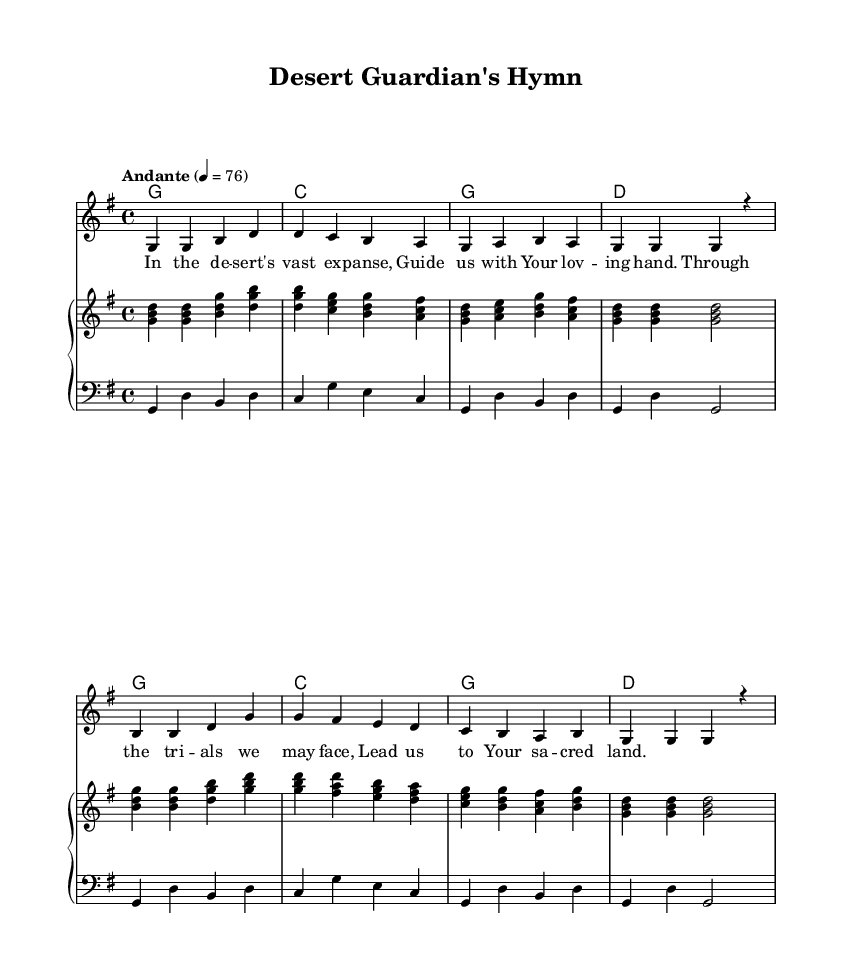What is the key signature of this music? The key signature is G major, which has one sharp (F#). You can identify the key signature by looking at the clef and the accidentals at the beginning of the sheet music.
Answer: G major What is the time signature of this piece? The time signature is 4/4, indicated at the beginning of the music. This means there are four beats in each measure and the quarter note gets one beat.
Answer: 4/4 What tempo marking is given in the score? The tempo marking is 'Andante', which indicates a moderate pace. It is usually performed at a speed of 76 beats per minute as noted in the score.
Answer: Andante How many measures are in the melody? The melody contains a total of eight measures. By counting the vertical lines that separate the measures, we can determine the total number of measures present in the piece.
Answer: Eight What is the main theme of the lyrics? The main theme of the lyrics revolves around seeking guidance and protection during trials in the desert. This is evident from phrases like "Guide us with Your loving hand" and "Through the trials we may face."
Answer: Guidance and protection Which chords are used in the first four measures? The chords used in the first four measures are G, C, G, and D. By looking at the chord names above the staff in the score, we can identify the sequence of chords played during these measures.
Answer: G, C, G, D What is the structure of the vocal music? The structure includes a melody and lyrics, demonstrated by the presence of a voice part for the melody with the corresponding lyrical text below it. This format is common in hymns to facilitate singing the text along with the melody.
Answer: Melody and lyrics 